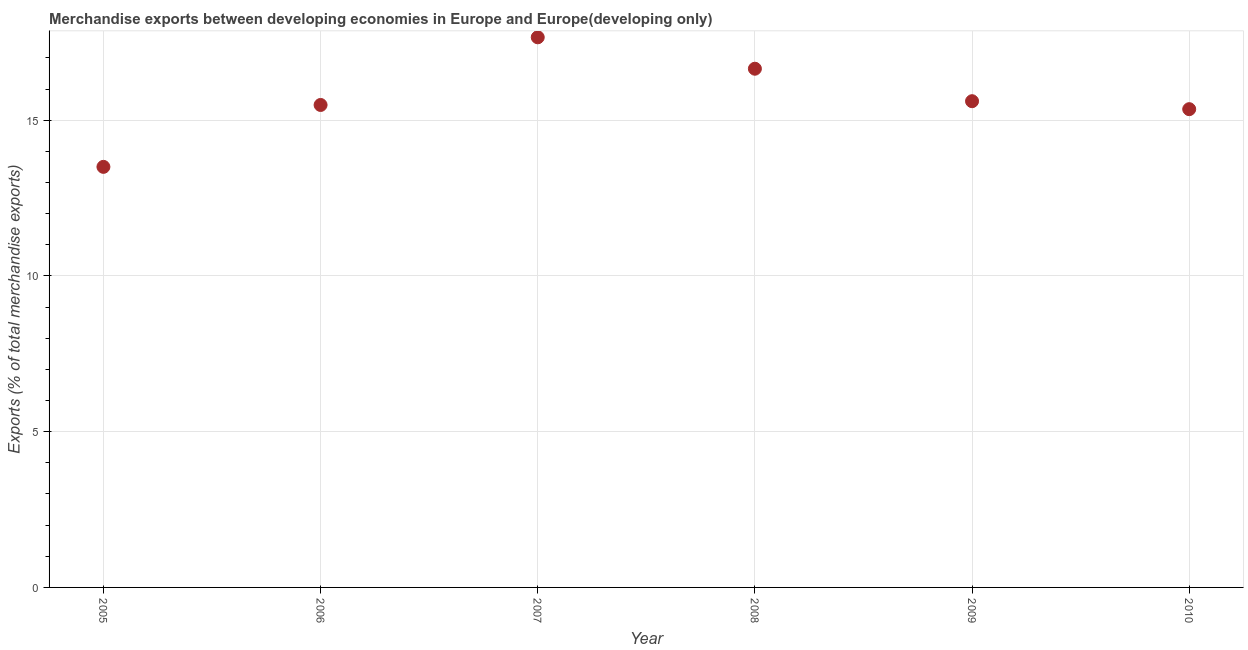What is the merchandise exports in 2007?
Your answer should be very brief. 17.66. Across all years, what is the maximum merchandise exports?
Ensure brevity in your answer.  17.66. Across all years, what is the minimum merchandise exports?
Make the answer very short. 13.5. In which year was the merchandise exports maximum?
Give a very brief answer. 2007. What is the sum of the merchandise exports?
Provide a succinct answer. 94.27. What is the difference between the merchandise exports in 2008 and 2009?
Offer a very short reply. 1.04. What is the average merchandise exports per year?
Provide a succinct answer. 15.71. What is the median merchandise exports?
Give a very brief answer. 15.55. What is the ratio of the merchandise exports in 2009 to that in 2010?
Provide a short and direct response. 1.02. Is the merchandise exports in 2006 less than that in 2007?
Your answer should be very brief. Yes. What is the difference between the highest and the second highest merchandise exports?
Your answer should be very brief. 1.01. What is the difference between the highest and the lowest merchandise exports?
Your answer should be very brief. 4.16. In how many years, is the merchandise exports greater than the average merchandise exports taken over all years?
Provide a short and direct response. 2. Does the merchandise exports monotonically increase over the years?
Your answer should be very brief. No. How many dotlines are there?
Ensure brevity in your answer.  1. How many years are there in the graph?
Provide a succinct answer. 6. What is the difference between two consecutive major ticks on the Y-axis?
Give a very brief answer. 5. Are the values on the major ticks of Y-axis written in scientific E-notation?
Keep it short and to the point. No. Does the graph contain any zero values?
Offer a very short reply. No. What is the title of the graph?
Offer a terse response. Merchandise exports between developing economies in Europe and Europe(developing only). What is the label or title of the Y-axis?
Offer a very short reply. Exports (% of total merchandise exports). What is the Exports (% of total merchandise exports) in 2005?
Your answer should be very brief. 13.5. What is the Exports (% of total merchandise exports) in 2006?
Make the answer very short. 15.49. What is the Exports (% of total merchandise exports) in 2007?
Offer a very short reply. 17.66. What is the Exports (% of total merchandise exports) in 2008?
Offer a very short reply. 16.65. What is the Exports (% of total merchandise exports) in 2009?
Make the answer very short. 15.61. What is the Exports (% of total merchandise exports) in 2010?
Your answer should be very brief. 15.35. What is the difference between the Exports (% of total merchandise exports) in 2005 and 2006?
Keep it short and to the point. -1.99. What is the difference between the Exports (% of total merchandise exports) in 2005 and 2007?
Your answer should be compact. -4.16. What is the difference between the Exports (% of total merchandise exports) in 2005 and 2008?
Your answer should be very brief. -3.15. What is the difference between the Exports (% of total merchandise exports) in 2005 and 2009?
Provide a short and direct response. -2.11. What is the difference between the Exports (% of total merchandise exports) in 2005 and 2010?
Your answer should be very brief. -1.85. What is the difference between the Exports (% of total merchandise exports) in 2006 and 2007?
Provide a succinct answer. -2.17. What is the difference between the Exports (% of total merchandise exports) in 2006 and 2008?
Keep it short and to the point. -1.16. What is the difference between the Exports (% of total merchandise exports) in 2006 and 2009?
Make the answer very short. -0.12. What is the difference between the Exports (% of total merchandise exports) in 2006 and 2010?
Your answer should be very brief. 0.13. What is the difference between the Exports (% of total merchandise exports) in 2007 and 2008?
Keep it short and to the point. 1.01. What is the difference between the Exports (% of total merchandise exports) in 2007 and 2009?
Your answer should be compact. 2.05. What is the difference between the Exports (% of total merchandise exports) in 2007 and 2010?
Ensure brevity in your answer.  2.31. What is the difference between the Exports (% of total merchandise exports) in 2008 and 2009?
Offer a very short reply. 1.04. What is the difference between the Exports (% of total merchandise exports) in 2008 and 2010?
Offer a very short reply. 1.3. What is the difference between the Exports (% of total merchandise exports) in 2009 and 2010?
Give a very brief answer. 0.26. What is the ratio of the Exports (% of total merchandise exports) in 2005 to that in 2006?
Ensure brevity in your answer.  0.87. What is the ratio of the Exports (% of total merchandise exports) in 2005 to that in 2007?
Your answer should be compact. 0.76. What is the ratio of the Exports (% of total merchandise exports) in 2005 to that in 2008?
Your answer should be very brief. 0.81. What is the ratio of the Exports (% of total merchandise exports) in 2005 to that in 2009?
Your answer should be very brief. 0.86. What is the ratio of the Exports (% of total merchandise exports) in 2005 to that in 2010?
Make the answer very short. 0.88. What is the ratio of the Exports (% of total merchandise exports) in 2006 to that in 2007?
Provide a short and direct response. 0.88. What is the ratio of the Exports (% of total merchandise exports) in 2006 to that in 2008?
Keep it short and to the point. 0.93. What is the ratio of the Exports (% of total merchandise exports) in 2006 to that in 2009?
Provide a short and direct response. 0.99. What is the ratio of the Exports (% of total merchandise exports) in 2007 to that in 2008?
Ensure brevity in your answer.  1.06. What is the ratio of the Exports (% of total merchandise exports) in 2007 to that in 2009?
Keep it short and to the point. 1.13. What is the ratio of the Exports (% of total merchandise exports) in 2007 to that in 2010?
Keep it short and to the point. 1.15. What is the ratio of the Exports (% of total merchandise exports) in 2008 to that in 2009?
Ensure brevity in your answer.  1.07. What is the ratio of the Exports (% of total merchandise exports) in 2008 to that in 2010?
Ensure brevity in your answer.  1.08. 